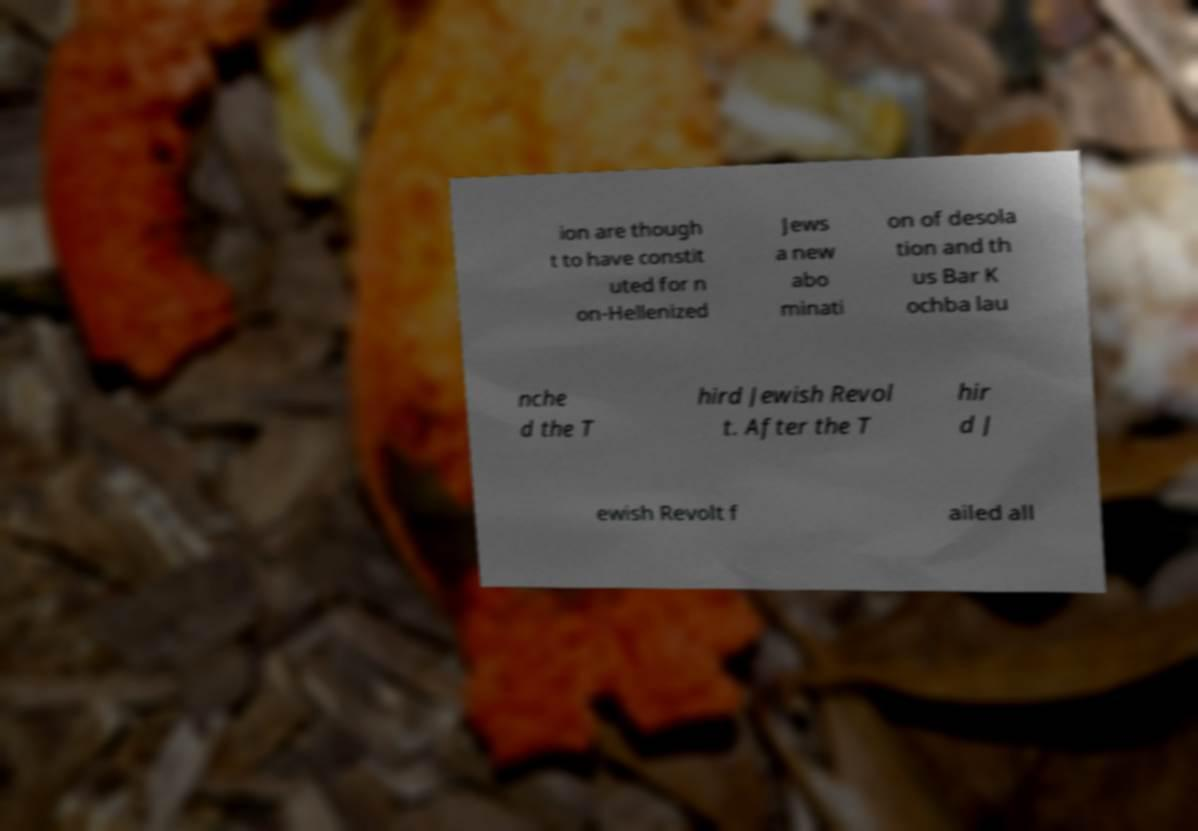Please read and relay the text visible in this image. What does it say? ion are though t to have constit uted for n on-Hellenized Jews a new abo minati on of desola tion and th us Bar K ochba lau nche d the T hird Jewish Revol t. After the T hir d J ewish Revolt f ailed all 